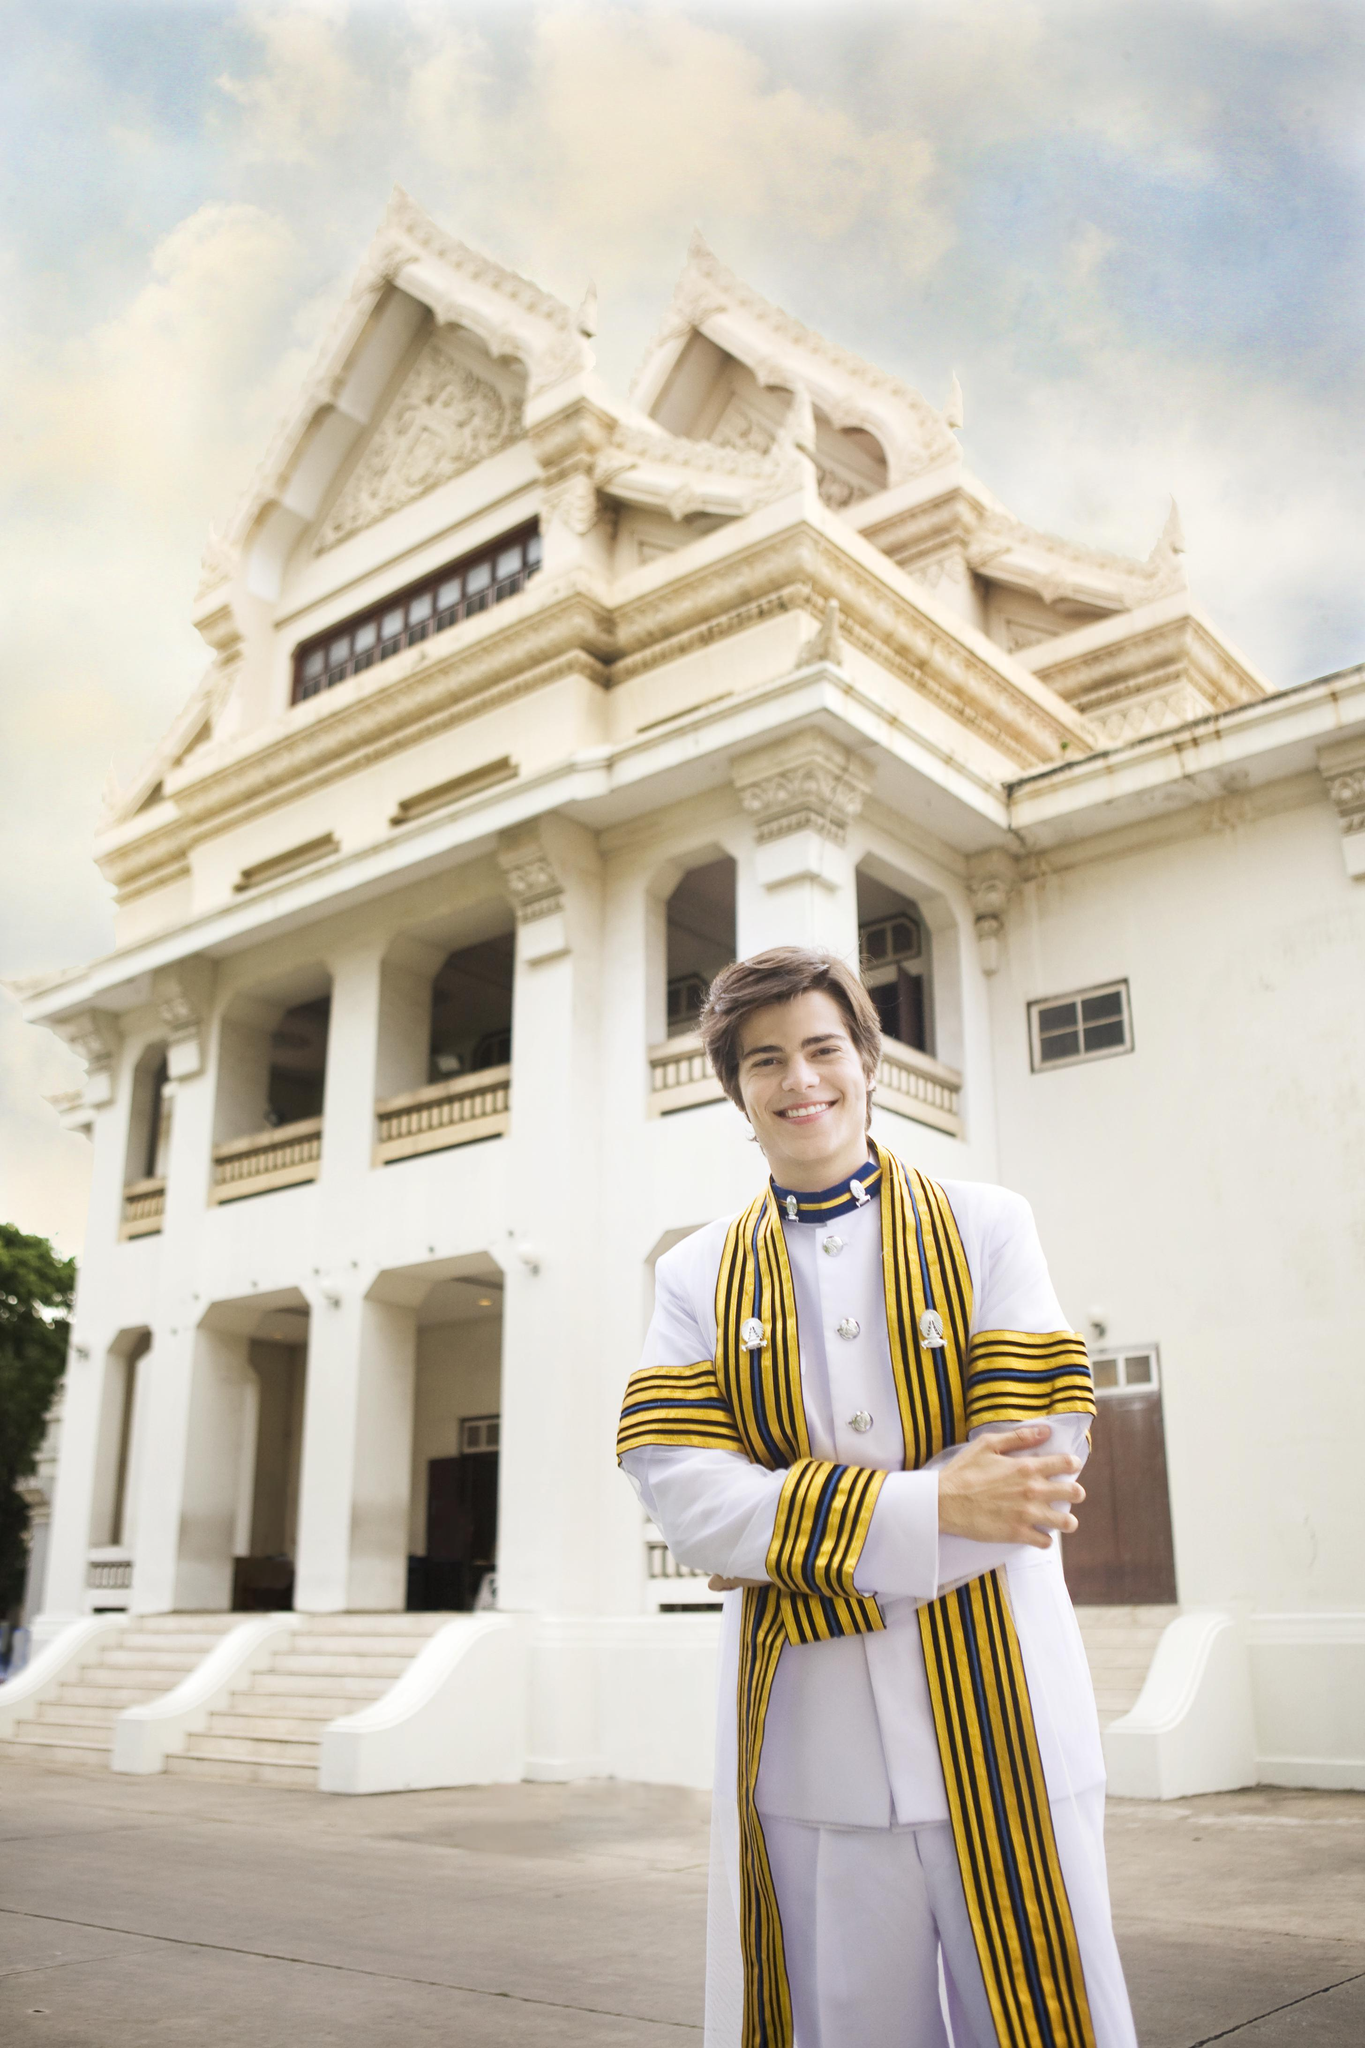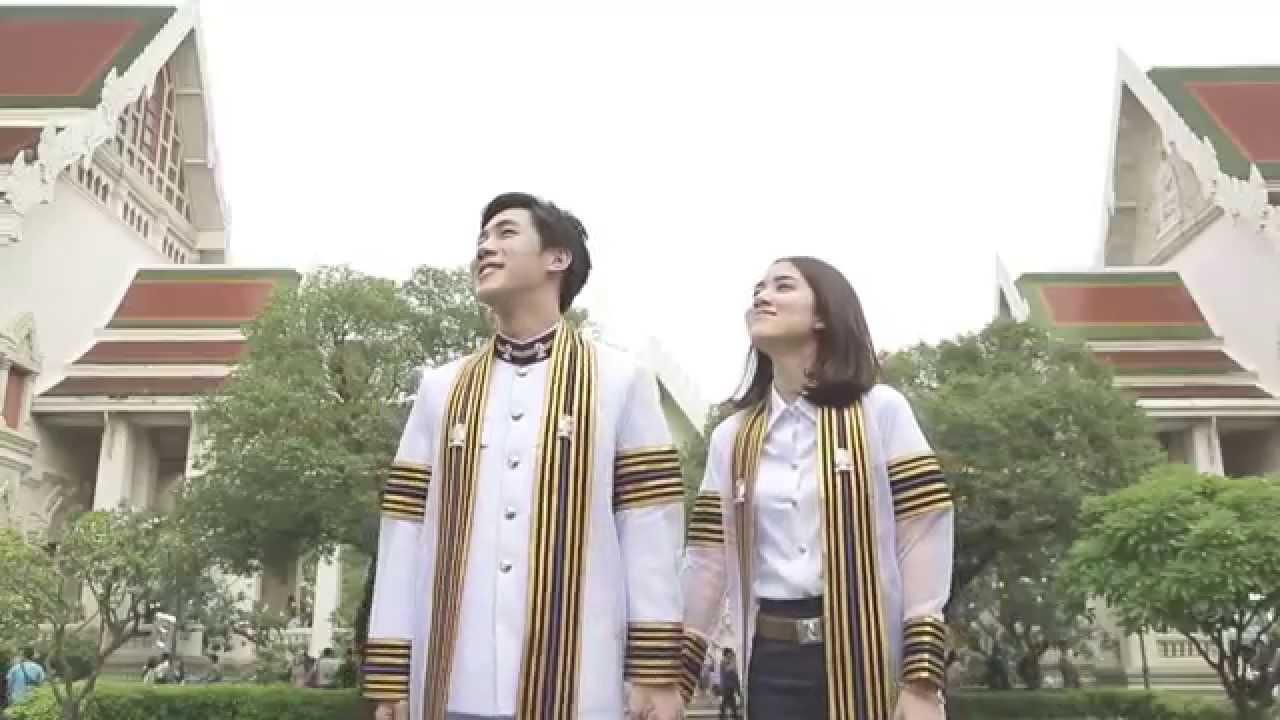The first image is the image on the left, the second image is the image on the right. Analyze the images presented: Is the assertion "A large congregation of people are lined up in rows outside in at least one picture." valid? Answer yes or no. No. The first image is the image on the left, the second image is the image on the right. Given the left and right images, does the statement "One of the images features a young man standing in front of a building." hold true? Answer yes or no. Yes. 